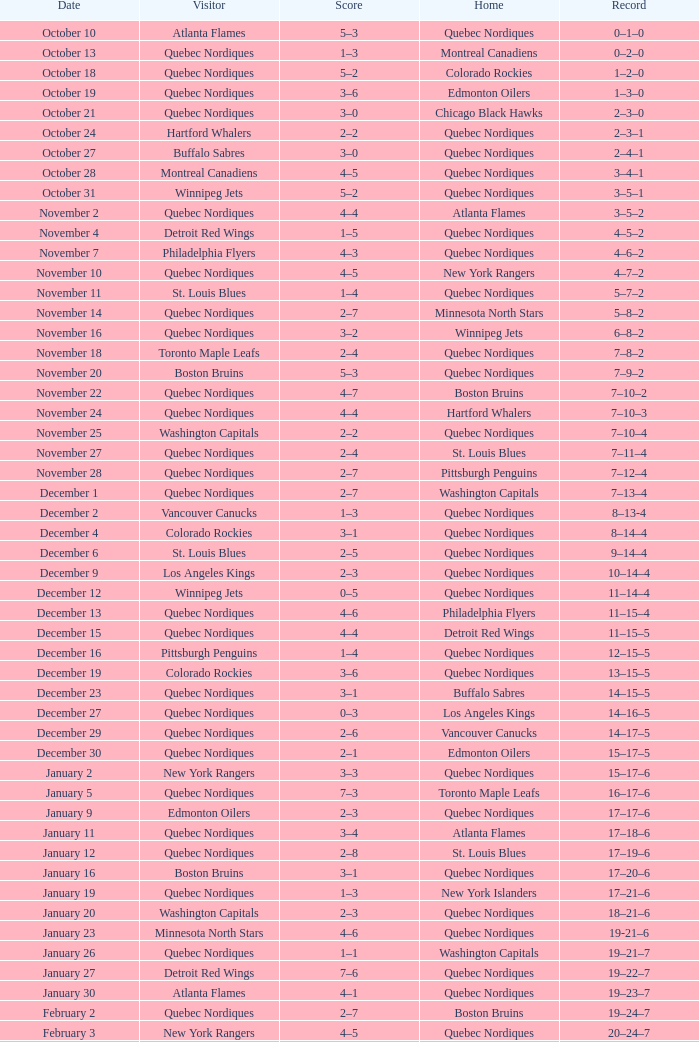Which Record has a Home of edmonton oilers, and a Score of 3–6? 1–3–0. 